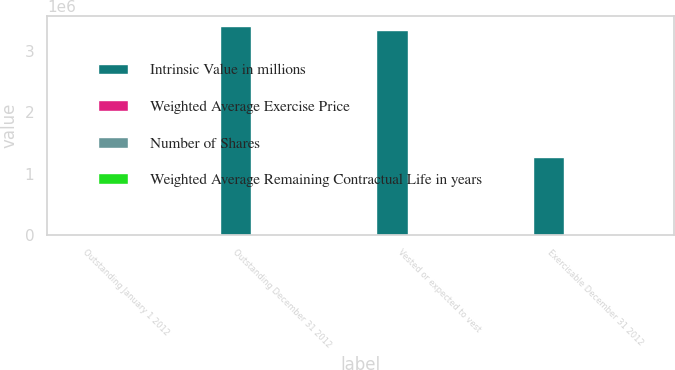<chart> <loc_0><loc_0><loc_500><loc_500><stacked_bar_chart><ecel><fcel>Outstanding January 1 2012<fcel>Outstanding December 31 2012<fcel>Vested or expected to vest<fcel>Exercisable December 31 2012<nl><fcel>Intrinsic Value in millions<fcel>71.34<fcel>3.4087e+06<fcel>3.34132e+06<fcel>1.27188e+06<nl><fcel>Weighted Average Exercise Price<fcel>60.52<fcel>71.34<fcel>71.05<fcel>57.78<nl><fcel>Number of Shares<fcel>5.6<fcel>6.6<fcel>6.6<fcel>4<nl><fcel>Weighted Average Remaining Contractual Life in years<fcel>116<fcel>218<fcel>215<fcel>99<nl></chart> 